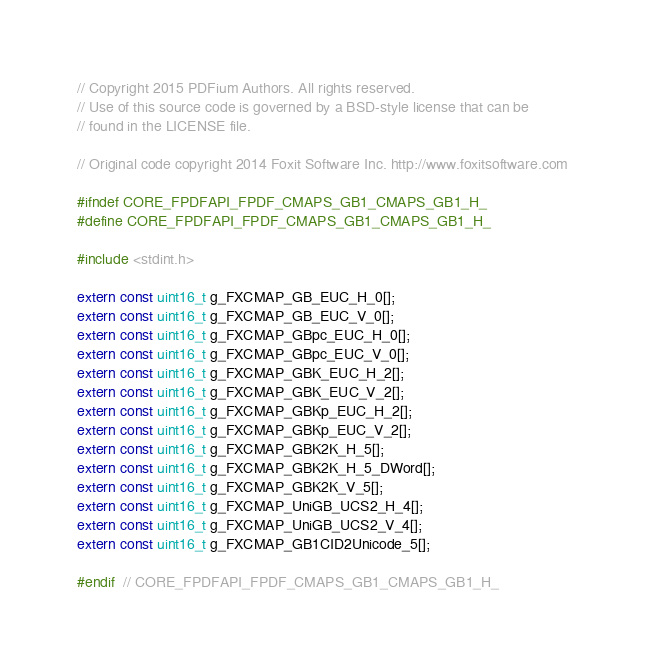Convert code to text. <code><loc_0><loc_0><loc_500><loc_500><_C_>// Copyright 2015 PDFium Authors. All rights reserved.
// Use of this source code is governed by a BSD-style license that can be
// found in the LICENSE file.

// Original code copyright 2014 Foxit Software Inc. http://www.foxitsoftware.com

#ifndef CORE_FPDFAPI_FPDF_CMAPS_GB1_CMAPS_GB1_H_
#define CORE_FPDFAPI_FPDF_CMAPS_GB1_CMAPS_GB1_H_

#include <stdint.h>

extern const uint16_t g_FXCMAP_GB_EUC_H_0[];
extern const uint16_t g_FXCMAP_GB_EUC_V_0[];
extern const uint16_t g_FXCMAP_GBpc_EUC_H_0[];
extern const uint16_t g_FXCMAP_GBpc_EUC_V_0[];
extern const uint16_t g_FXCMAP_GBK_EUC_H_2[];
extern const uint16_t g_FXCMAP_GBK_EUC_V_2[];
extern const uint16_t g_FXCMAP_GBKp_EUC_H_2[];
extern const uint16_t g_FXCMAP_GBKp_EUC_V_2[];
extern const uint16_t g_FXCMAP_GBK2K_H_5[];
extern const uint16_t g_FXCMAP_GBK2K_H_5_DWord[];
extern const uint16_t g_FXCMAP_GBK2K_V_5[];
extern const uint16_t g_FXCMAP_UniGB_UCS2_H_4[];
extern const uint16_t g_FXCMAP_UniGB_UCS2_V_4[];
extern const uint16_t g_FXCMAP_GB1CID2Unicode_5[];

#endif  // CORE_FPDFAPI_FPDF_CMAPS_GB1_CMAPS_GB1_H_
</code> 